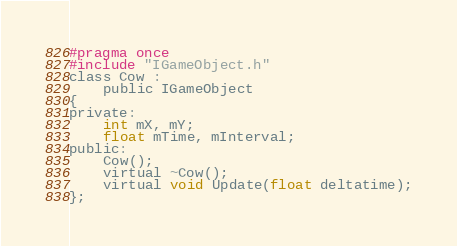Convert code to text. <code><loc_0><loc_0><loc_500><loc_500><_C_>#pragma once
#include "IGameObject.h"
class Cow :
	public IGameObject
{
private:
	int mX, mY;
	float mTime, mInterval;
public:
	Cow();
	virtual ~Cow();
	virtual void Update(float deltatime);
};

</code> 